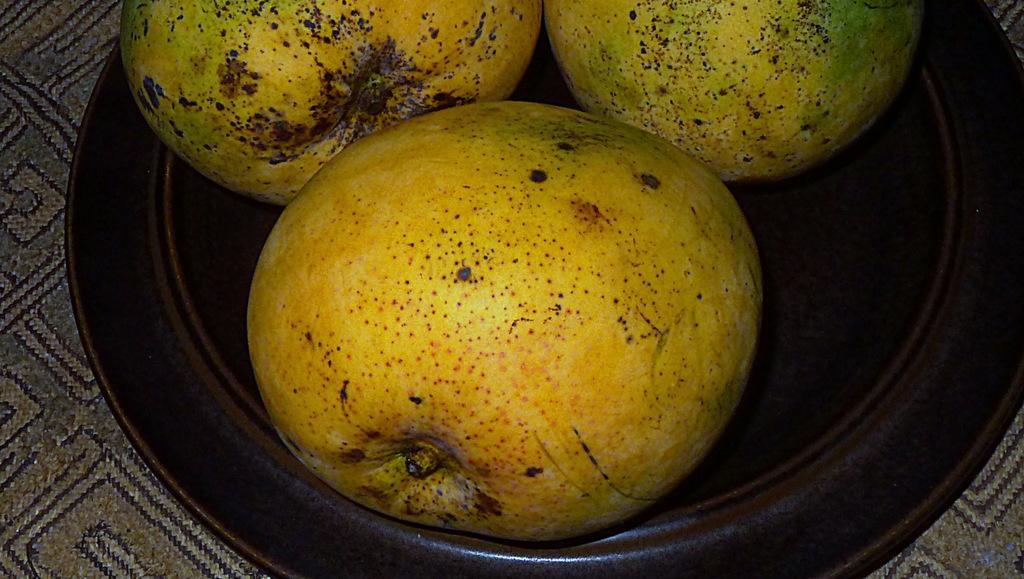Could you give a brief overview of what you see in this image? In this picture there fruits on the plate and the plate is in brown color. At the bottom there is a cloth. 